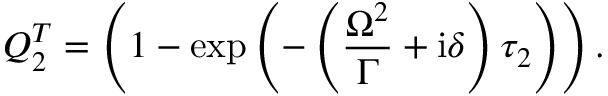Convert formula to latex. <formula><loc_0><loc_0><loc_500><loc_500>Q _ { 2 } ^ { T } = \left ( 1 - \exp \left ( - \left ( \frac { \Omega ^ { 2 } } { \Gamma } + i \delta \right ) \tau _ { 2 } \right ) \right ) .</formula> 